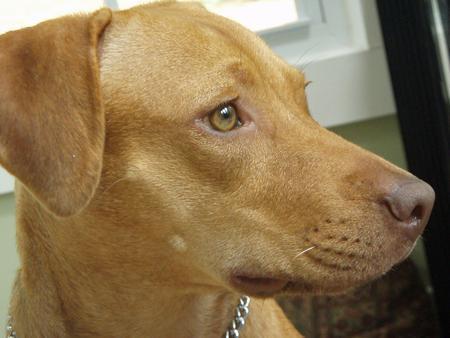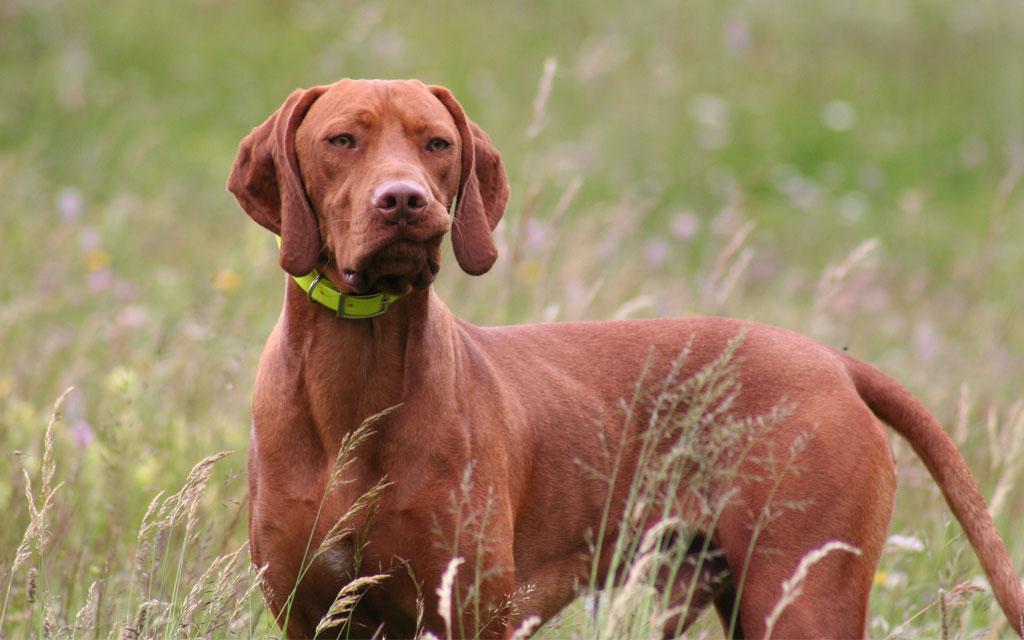The first image is the image on the left, the second image is the image on the right. Considering the images on both sides, is "One of the dogs has a green collar." valid? Answer yes or no. Yes. The first image is the image on the left, the second image is the image on the right. Analyze the images presented: Is the assertion "One image shows a dark red-orange dog standing and wearing a lime green collar, and the other image features a more tan dog with something around its neck." valid? Answer yes or no. Yes. 